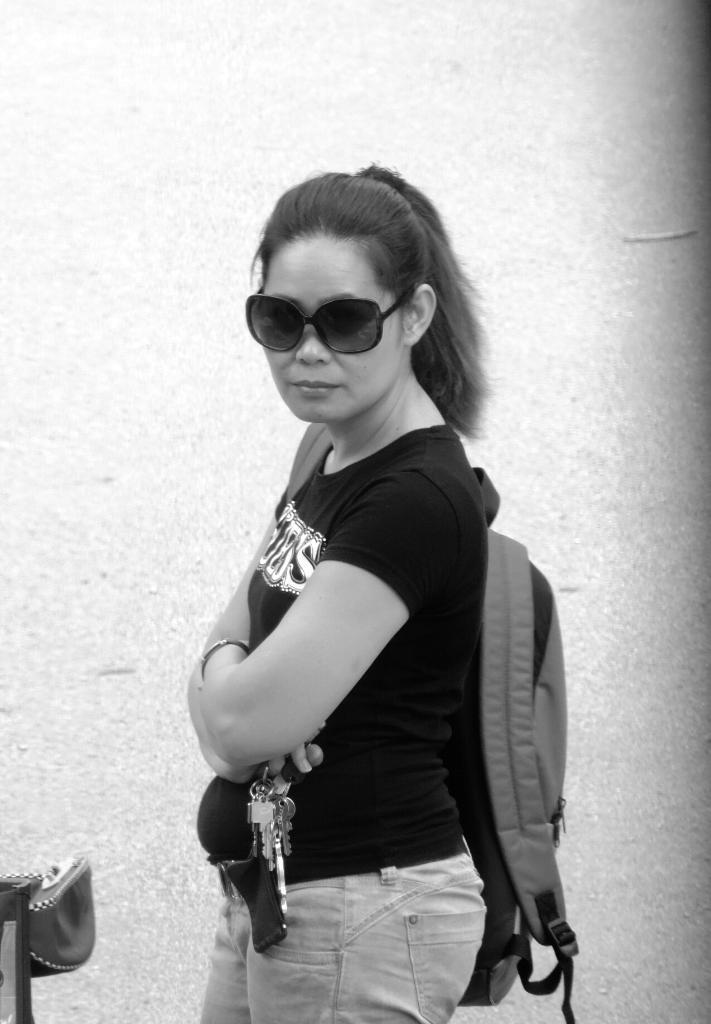How would you summarize this image in a sentence or two? This is a black and white image. In this image we can see a woman standing wearing a bag holding some keys. On the left side we can see an object. 